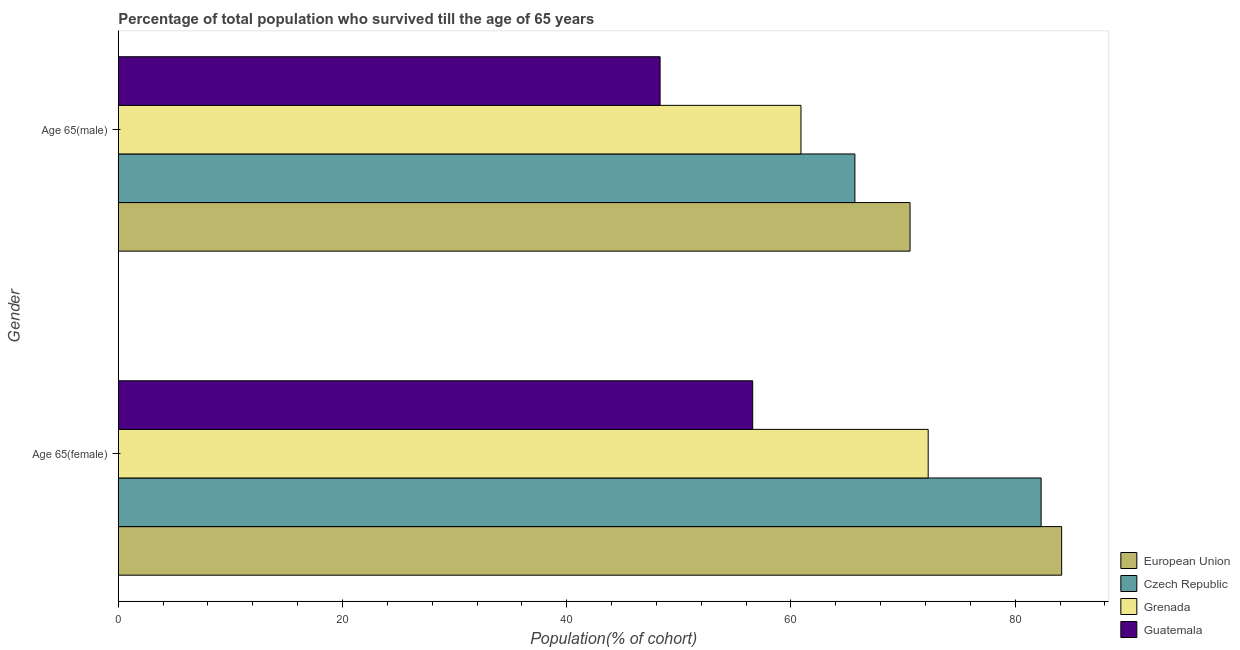How many different coloured bars are there?
Provide a short and direct response. 4. Are the number of bars per tick equal to the number of legend labels?
Your answer should be very brief. Yes. Are the number of bars on each tick of the Y-axis equal?
Your answer should be compact. Yes. What is the label of the 2nd group of bars from the top?
Offer a terse response. Age 65(female). What is the percentage of female population who survived till age of 65 in Grenada?
Keep it short and to the point. 72.24. Across all countries, what is the maximum percentage of male population who survived till age of 65?
Give a very brief answer. 70.62. Across all countries, what is the minimum percentage of female population who survived till age of 65?
Offer a very short reply. 56.59. In which country was the percentage of female population who survived till age of 65 minimum?
Your answer should be compact. Guatemala. What is the total percentage of male population who survived till age of 65 in the graph?
Make the answer very short. 245.54. What is the difference between the percentage of male population who survived till age of 65 in European Union and that in Czech Republic?
Provide a succinct answer. 4.92. What is the difference between the percentage of male population who survived till age of 65 in Czech Republic and the percentage of female population who survived till age of 65 in Grenada?
Offer a terse response. -6.54. What is the average percentage of male population who survived till age of 65 per country?
Offer a very short reply. 61.39. What is the difference between the percentage of female population who survived till age of 65 and percentage of male population who survived till age of 65 in Grenada?
Provide a short and direct response. 11.35. In how many countries, is the percentage of female population who survived till age of 65 greater than 60 %?
Give a very brief answer. 3. What is the ratio of the percentage of female population who survived till age of 65 in Guatemala to that in Grenada?
Give a very brief answer. 0.78. What does the 2nd bar from the top in Age 65(male) represents?
Offer a very short reply. Grenada. What does the 1st bar from the bottom in Age 65(male) represents?
Your answer should be compact. European Union. How many bars are there?
Your response must be concise. 8. Are all the bars in the graph horizontal?
Offer a terse response. Yes. Are the values on the major ticks of X-axis written in scientific E-notation?
Your answer should be compact. No. What is the title of the graph?
Offer a very short reply. Percentage of total population who survived till the age of 65 years. Does "Somalia" appear as one of the legend labels in the graph?
Give a very brief answer. No. What is the label or title of the X-axis?
Your response must be concise. Population(% of cohort). What is the Population(% of cohort) in European Union in Age 65(female)?
Offer a very short reply. 84.14. What is the Population(% of cohort) in Czech Republic in Age 65(female)?
Offer a terse response. 82.31. What is the Population(% of cohort) in Grenada in Age 65(female)?
Offer a terse response. 72.24. What is the Population(% of cohort) of Guatemala in Age 65(female)?
Keep it short and to the point. 56.59. What is the Population(% of cohort) of European Union in Age 65(male)?
Ensure brevity in your answer.  70.62. What is the Population(% of cohort) of Czech Republic in Age 65(male)?
Keep it short and to the point. 65.7. What is the Population(% of cohort) in Grenada in Age 65(male)?
Provide a short and direct response. 60.89. What is the Population(% of cohort) of Guatemala in Age 65(male)?
Make the answer very short. 48.33. Across all Gender, what is the maximum Population(% of cohort) of European Union?
Ensure brevity in your answer.  84.14. Across all Gender, what is the maximum Population(% of cohort) of Czech Republic?
Offer a terse response. 82.31. Across all Gender, what is the maximum Population(% of cohort) of Grenada?
Keep it short and to the point. 72.24. Across all Gender, what is the maximum Population(% of cohort) of Guatemala?
Make the answer very short. 56.59. Across all Gender, what is the minimum Population(% of cohort) of European Union?
Your answer should be very brief. 70.62. Across all Gender, what is the minimum Population(% of cohort) of Czech Republic?
Provide a succinct answer. 65.7. Across all Gender, what is the minimum Population(% of cohort) in Grenada?
Offer a very short reply. 60.89. Across all Gender, what is the minimum Population(% of cohort) in Guatemala?
Provide a short and direct response. 48.33. What is the total Population(% of cohort) of European Union in the graph?
Keep it short and to the point. 154.77. What is the total Population(% of cohort) in Czech Republic in the graph?
Your answer should be very brief. 148.02. What is the total Population(% of cohort) of Grenada in the graph?
Provide a short and direct response. 133.13. What is the total Population(% of cohort) of Guatemala in the graph?
Keep it short and to the point. 104.91. What is the difference between the Population(% of cohort) in European Union in Age 65(female) and that in Age 65(male)?
Make the answer very short. 13.52. What is the difference between the Population(% of cohort) of Czech Republic in Age 65(female) and that in Age 65(male)?
Offer a very short reply. 16.61. What is the difference between the Population(% of cohort) of Grenada in Age 65(female) and that in Age 65(male)?
Offer a terse response. 11.35. What is the difference between the Population(% of cohort) of Guatemala in Age 65(female) and that in Age 65(male)?
Provide a short and direct response. 8.26. What is the difference between the Population(% of cohort) in European Union in Age 65(female) and the Population(% of cohort) in Czech Republic in Age 65(male)?
Make the answer very short. 18.44. What is the difference between the Population(% of cohort) in European Union in Age 65(female) and the Population(% of cohort) in Grenada in Age 65(male)?
Provide a short and direct response. 23.25. What is the difference between the Population(% of cohort) of European Union in Age 65(female) and the Population(% of cohort) of Guatemala in Age 65(male)?
Offer a terse response. 35.82. What is the difference between the Population(% of cohort) in Czech Republic in Age 65(female) and the Population(% of cohort) in Grenada in Age 65(male)?
Give a very brief answer. 21.42. What is the difference between the Population(% of cohort) in Czech Republic in Age 65(female) and the Population(% of cohort) in Guatemala in Age 65(male)?
Ensure brevity in your answer.  33.99. What is the difference between the Population(% of cohort) of Grenada in Age 65(female) and the Population(% of cohort) of Guatemala in Age 65(male)?
Make the answer very short. 23.91. What is the average Population(% of cohort) in European Union per Gender?
Your answer should be compact. 77.38. What is the average Population(% of cohort) of Czech Republic per Gender?
Your answer should be very brief. 74.01. What is the average Population(% of cohort) in Grenada per Gender?
Give a very brief answer. 66.57. What is the average Population(% of cohort) of Guatemala per Gender?
Offer a very short reply. 52.46. What is the difference between the Population(% of cohort) in European Union and Population(% of cohort) in Czech Republic in Age 65(female)?
Provide a short and direct response. 1.83. What is the difference between the Population(% of cohort) in European Union and Population(% of cohort) in Grenada in Age 65(female)?
Make the answer very short. 11.9. What is the difference between the Population(% of cohort) in European Union and Population(% of cohort) in Guatemala in Age 65(female)?
Provide a succinct answer. 27.56. What is the difference between the Population(% of cohort) in Czech Republic and Population(% of cohort) in Grenada in Age 65(female)?
Keep it short and to the point. 10.07. What is the difference between the Population(% of cohort) in Czech Republic and Population(% of cohort) in Guatemala in Age 65(female)?
Keep it short and to the point. 25.73. What is the difference between the Population(% of cohort) of Grenada and Population(% of cohort) of Guatemala in Age 65(female)?
Provide a short and direct response. 15.65. What is the difference between the Population(% of cohort) of European Union and Population(% of cohort) of Czech Republic in Age 65(male)?
Make the answer very short. 4.92. What is the difference between the Population(% of cohort) in European Union and Population(% of cohort) in Grenada in Age 65(male)?
Offer a terse response. 9.73. What is the difference between the Population(% of cohort) of European Union and Population(% of cohort) of Guatemala in Age 65(male)?
Ensure brevity in your answer.  22.29. What is the difference between the Population(% of cohort) of Czech Republic and Population(% of cohort) of Grenada in Age 65(male)?
Your answer should be very brief. 4.81. What is the difference between the Population(% of cohort) in Czech Republic and Population(% of cohort) in Guatemala in Age 65(male)?
Keep it short and to the point. 17.37. What is the difference between the Population(% of cohort) of Grenada and Population(% of cohort) of Guatemala in Age 65(male)?
Make the answer very short. 12.57. What is the ratio of the Population(% of cohort) in European Union in Age 65(female) to that in Age 65(male)?
Provide a succinct answer. 1.19. What is the ratio of the Population(% of cohort) of Czech Republic in Age 65(female) to that in Age 65(male)?
Your response must be concise. 1.25. What is the ratio of the Population(% of cohort) in Grenada in Age 65(female) to that in Age 65(male)?
Ensure brevity in your answer.  1.19. What is the ratio of the Population(% of cohort) in Guatemala in Age 65(female) to that in Age 65(male)?
Provide a short and direct response. 1.17. What is the difference between the highest and the second highest Population(% of cohort) in European Union?
Your answer should be very brief. 13.52. What is the difference between the highest and the second highest Population(% of cohort) of Czech Republic?
Your answer should be compact. 16.61. What is the difference between the highest and the second highest Population(% of cohort) of Grenada?
Offer a very short reply. 11.35. What is the difference between the highest and the second highest Population(% of cohort) in Guatemala?
Provide a short and direct response. 8.26. What is the difference between the highest and the lowest Population(% of cohort) in European Union?
Keep it short and to the point. 13.52. What is the difference between the highest and the lowest Population(% of cohort) in Czech Republic?
Your response must be concise. 16.61. What is the difference between the highest and the lowest Population(% of cohort) in Grenada?
Your response must be concise. 11.35. What is the difference between the highest and the lowest Population(% of cohort) of Guatemala?
Your answer should be compact. 8.26. 